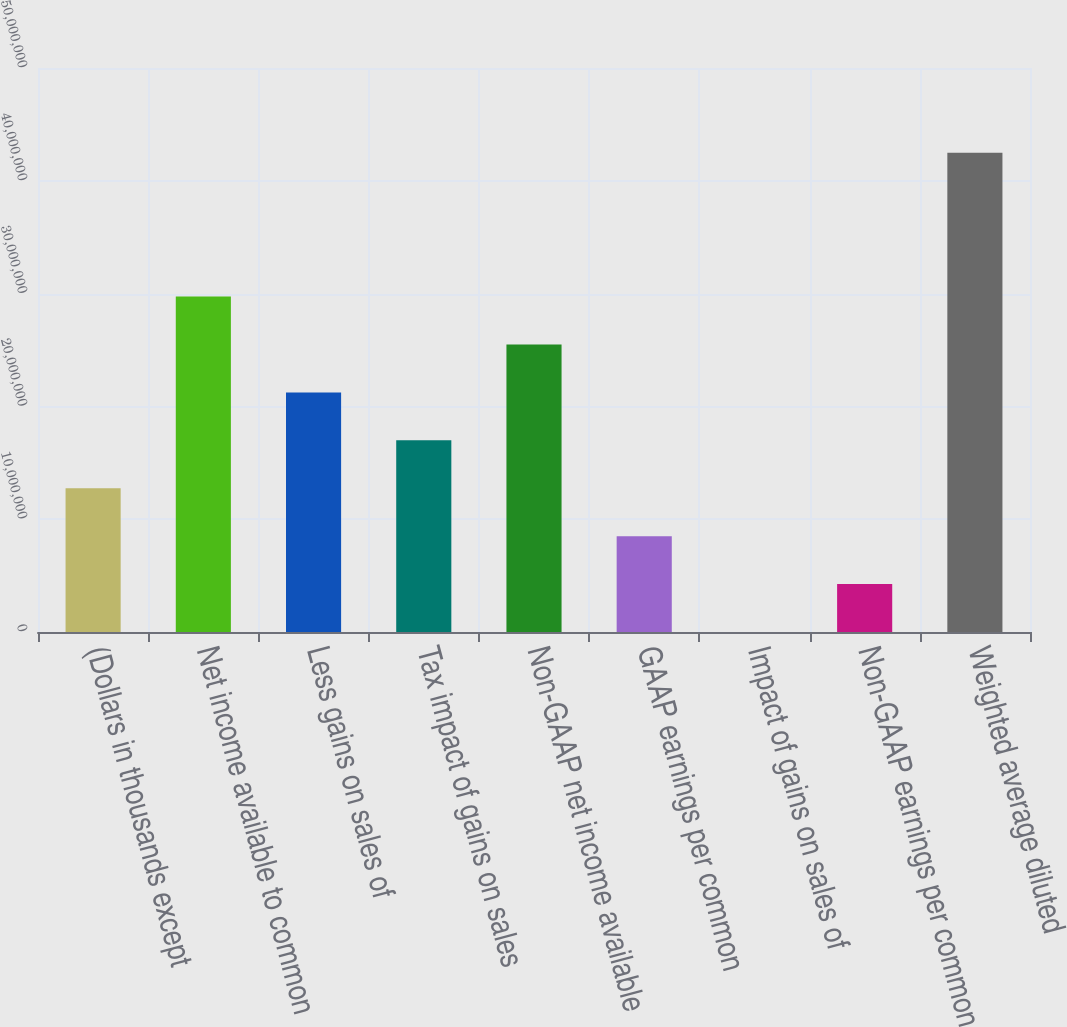Convert chart. <chart><loc_0><loc_0><loc_500><loc_500><bar_chart><fcel>(Dollars in thousands except<fcel>Net income available to common<fcel>Less gains on sales of<fcel>Tax impact of gains on sales<fcel>Non-GAAP net income available<fcel>GAAP earnings per common<fcel>Impact of gains on sales of<fcel>Non-GAAP earnings per common<fcel>Weighted average diluted<nl><fcel>1.27435e+07<fcel>2.97348e+07<fcel>2.12392e+07<fcel>1.69913e+07<fcel>2.5487e+07<fcel>8.49567e+06<fcel>0.58<fcel>4.24783e+06<fcel>4.24783e+07<nl></chart> 